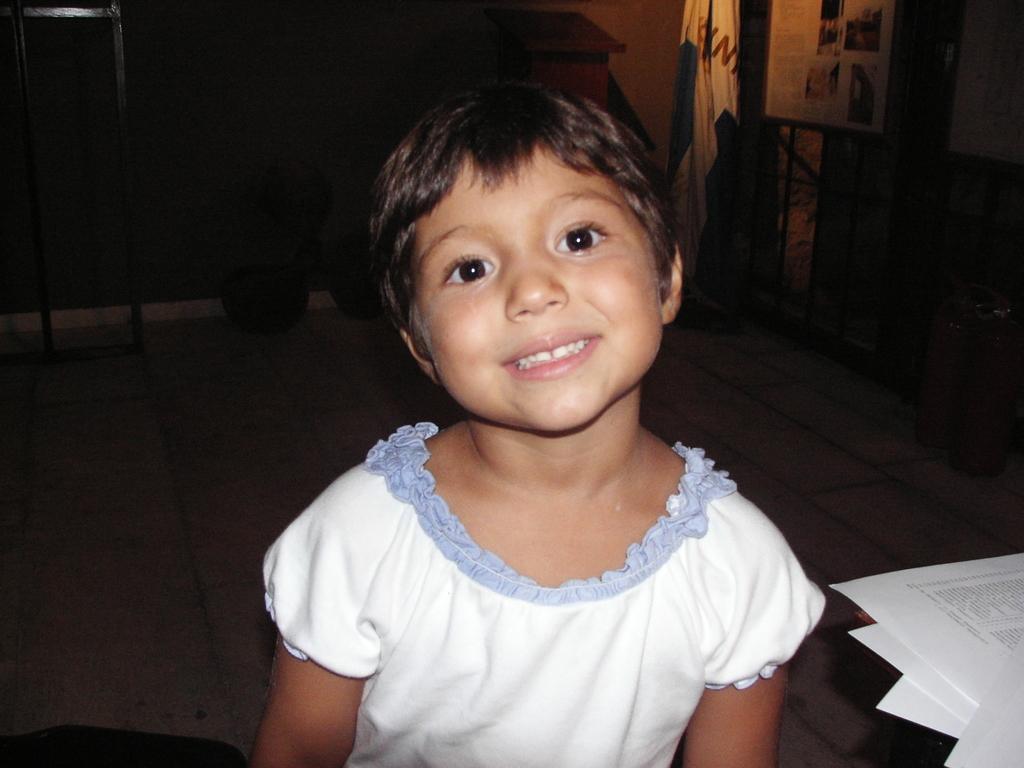In one or two sentences, can you explain what this image depicts? Background portion of the picture is dark and we can see a board and few objects. In this picture we can see a girl is smiling. On the right side of the picture we can see papers. 